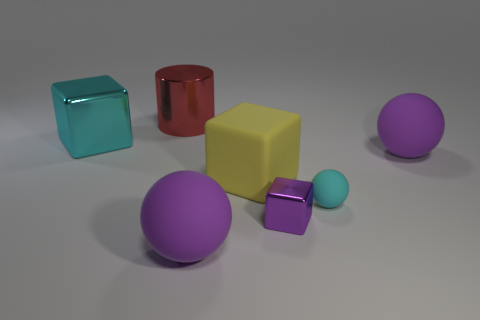Can you describe the shapes and colors visible in the image? Certainly, the image features a variety of geometric shapes with smooth surfaces. There's a large yellow cube, a large red cylinder with a metallic finish, a large purple sphere, and two smaller objects: a purple sphere and a teal cube. All the objects are set against a neutral background, and the lighting casts soft shadows beneath them. 